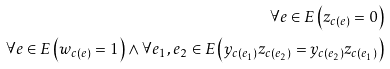<formula> <loc_0><loc_0><loc_500><loc_500>\forall { e \in E } \left ( z _ { c ( e ) } = 0 \right ) \\ \forall { e \in E } \left ( w _ { c ( e ) } = 1 \right ) \wedge \forall { e _ { 1 } , e _ { 2 } \in E } \left ( y _ { c ( e _ { 1 } ) } z _ { c ( e _ { 2 } ) } = y _ { c ( e _ { 2 } ) } z _ { c ( e _ { 1 } ) } \right )</formula> 